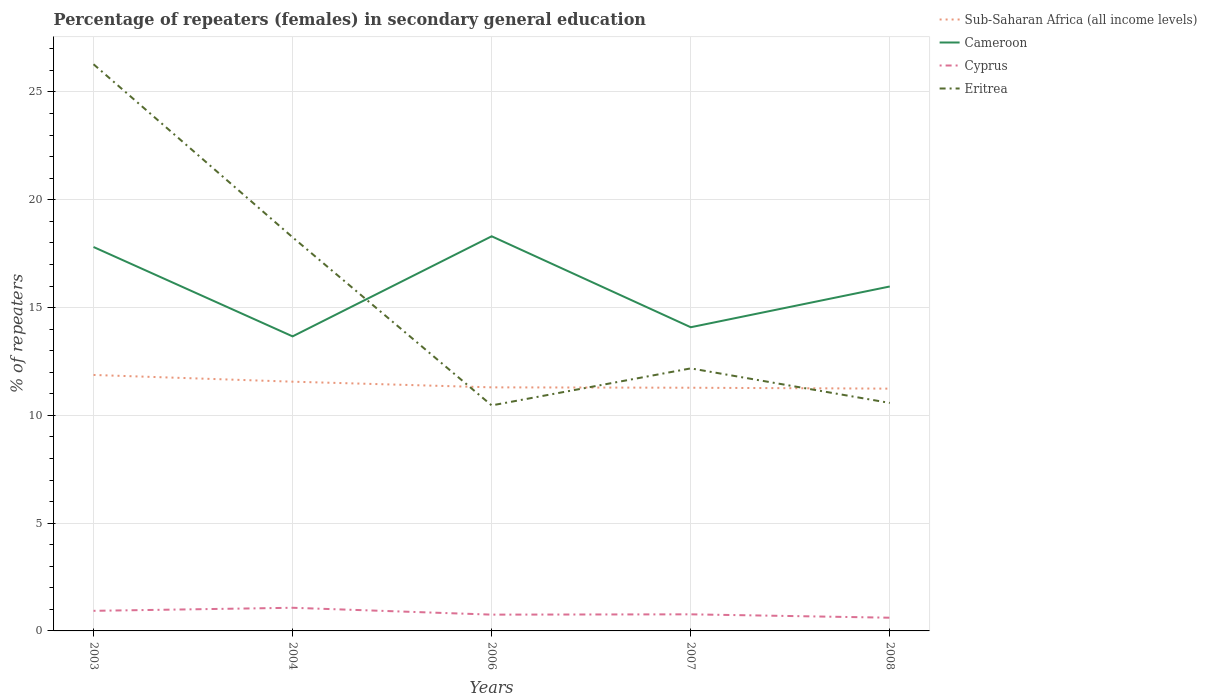How many different coloured lines are there?
Provide a succinct answer. 4. Does the line corresponding to Eritrea intersect with the line corresponding to Cyprus?
Your answer should be compact. No. Is the number of lines equal to the number of legend labels?
Provide a short and direct response. Yes. Across all years, what is the maximum percentage of female repeaters in Cameroon?
Provide a succinct answer. 13.66. In which year was the percentage of female repeaters in Cameroon maximum?
Give a very brief answer. 2004. What is the total percentage of female repeaters in Cyprus in the graph?
Provide a succinct answer. 0.32. What is the difference between the highest and the second highest percentage of female repeaters in Sub-Saharan Africa (all income levels)?
Your answer should be very brief. 0.64. Are the values on the major ticks of Y-axis written in scientific E-notation?
Your answer should be very brief. No. Does the graph contain any zero values?
Offer a terse response. No. Where does the legend appear in the graph?
Ensure brevity in your answer.  Top right. How are the legend labels stacked?
Give a very brief answer. Vertical. What is the title of the graph?
Make the answer very short. Percentage of repeaters (females) in secondary general education. What is the label or title of the X-axis?
Offer a very short reply. Years. What is the label or title of the Y-axis?
Keep it short and to the point. % of repeaters. What is the % of repeaters in Sub-Saharan Africa (all income levels) in 2003?
Offer a very short reply. 11.87. What is the % of repeaters of Cameroon in 2003?
Provide a succinct answer. 17.81. What is the % of repeaters in Cyprus in 2003?
Ensure brevity in your answer.  0.93. What is the % of repeaters in Eritrea in 2003?
Your answer should be very brief. 26.29. What is the % of repeaters in Sub-Saharan Africa (all income levels) in 2004?
Provide a short and direct response. 11.56. What is the % of repeaters of Cameroon in 2004?
Provide a short and direct response. 13.66. What is the % of repeaters of Cyprus in 2004?
Your answer should be compact. 1.07. What is the % of repeaters of Eritrea in 2004?
Provide a succinct answer. 18.26. What is the % of repeaters of Sub-Saharan Africa (all income levels) in 2006?
Provide a short and direct response. 11.3. What is the % of repeaters in Cameroon in 2006?
Provide a short and direct response. 18.31. What is the % of repeaters in Cyprus in 2006?
Keep it short and to the point. 0.76. What is the % of repeaters in Eritrea in 2006?
Offer a terse response. 10.46. What is the % of repeaters of Sub-Saharan Africa (all income levels) in 2007?
Provide a short and direct response. 11.28. What is the % of repeaters of Cameroon in 2007?
Make the answer very short. 14.09. What is the % of repeaters in Cyprus in 2007?
Your answer should be very brief. 0.77. What is the % of repeaters of Eritrea in 2007?
Ensure brevity in your answer.  12.18. What is the % of repeaters of Sub-Saharan Africa (all income levels) in 2008?
Your answer should be compact. 11.24. What is the % of repeaters in Cameroon in 2008?
Your answer should be compact. 15.98. What is the % of repeaters of Cyprus in 2008?
Make the answer very short. 0.61. What is the % of repeaters in Eritrea in 2008?
Provide a short and direct response. 10.58. Across all years, what is the maximum % of repeaters of Sub-Saharan Africa (all income levels)?
Give a very brief answer. 11.87. Across all years, what is the maximum % of repeaters in Cameroon?
Ensure brevity in your answer.  18.31. Across all years, what is the maximum % of repeaters in Cyprus?
Give a very brief answer. 1.07. Across all years, what is the maximum % of repeaters in Eritrea?
Offer a very short reply. 26.29. Across all years, what is the minimum % of repeaters of Sub-Saharan Africa (all income levels)?
Your response must be concise. 11.24. Across all years, what is the minimum % of repeaters in Cameroon?
Your response must be concise. 13.66. Across all years, what is the minimum % of repeaters in Cyprus?
Offer a terse response. 0.61. Across all years, what is the minimum % of repeaters in Eritrea?
Your response must be concise. 10.46. What is the total % of repeaters of Sub-Saharan Africa (all income levels) in the graph?
Your answer should be very brief. 57.26. What is the total % of repeaters of Cameroon in the graph?
Give a very brief answer. 79.85. What is the total % of repeaters of Cyprus in the graph?
Make the answer very short. 4.14. What is the total % of repeaters in Eritrea in the graph?
Make the answer very short. 77.76. What is the difference between the % of repeaters of Sub-Saharan Africa (all income levels) in 2003 and that in 2004?
Provide a short and direct response. 0.31. What is the difference between the % of repeaters of Cameroon in 2003 and that in 2004?
Provide a short and direct response. 4.15. What is the difference between the % of repeaters of Cyprus in 2003 and that in 2004?
Provide a succinct answer. -0.14. What is the difference between the % of repeaters of Eritrea in 2003 and that in 2004?
Provide a succinct answer. 8.03. What is the difference between the % of repeaters of Sub-Saharan Africa (all income levels) in 2003 and that in 2006?
Give a very brief answer. 0.58. What is the difference between the % of repeaters in Cameroon in 2003 and that in 2006?
Your response must be concise. -0.5. What is the difference between the % of repeaters of Cyprus in 2003 and that in 2006?
Give a very brief answer. 0.18. What is the difference between the % of repeaters of Eritrea in 2003 and that in 2006?
Provide a short and direct response. 15.83. What is the difference between the % of repeaters in Sub-Saharan Africa (all income levels) in 2003 and that in 2007?
Ensure brevity in your answer.  0.59. What is the difference between the % of repeaters in Cameroon in 2003 and that in 2007?
Your response must be concise. 3.72. What is the difference between the % of repeaters in Cyprus in 2003 and that in 2007?
Your response must be concise. 0.16. What is the difference between the % of repeaters in Eritrea in 2003 and that in 2007?
Keep it short and to the point. 14.11. What is the difference between the % of repeaters in Sub-Saharan Africa (all income levels) in 2003 and that in 2008?
Make the answer very short. 0.64. What is the difference between the % of repeaters of Cameroon in 2003 and that in 2008?
Your response must be concise. 1.83. What is the difference between the % of repeaters in Cyprus in 2003 and that in 2008?
Give a very brief answer. 0.32. What is the difference between the % of repeaters in Eritrea in 2003 and that in 2008?
Provide a succinct answer. 15.71. What is the difference between the % of repeaters in Sub-Saharan Africa (all income levels) in 2004 and that in 2006?
Your response must be concise. 0.26. What is the difference between the % of repeaters in Cameroon in 2004 and that in 2006?
Give a very brief answer. -4.64. What is the difference between the % of repeaters of Cyprus in 2004 and that in 2006?
Offer a very short reply. 0.32. What is the difference between the % of repeaters in Eritrea in 2004 and that in 2006?
Your answer should be compact. 7.8. What is the difference between the % of repeaters of Sub-Saharan Africa (all income levels) in 2004 and that in 2007?
Your response must be concise. 0.28. What is the difference between the % of repeaters of Cameroon in 2004 and that in 2007?
Keep it short and to the point. -0.42. What is the difference between the % of repeaters in Cyprus in 2004 and that in 2007?
Keep it short and to the point. 0.3. What is the difference between the % of repeaters in Eritrea in 2004 and that in 2007?
Make the answer very short. 6.08. What is the difference between the % of repeaters in Sub-Saharan Africa (all income levels) in 2004 and that in 2008?
Keep it short and to the point. 0.32. What is the difference between the % of repeaters of Cameroon in 2004 and that in 2008?
Your response must be concise. -2.31. What is the difference between the % of repeaters in Cyprus in 2004 and that in 2008?
Provide a short and direct response. 0.46. What is the difference between the % of repeaters in Eritrea in 2004 and that in 2008?
Ensure brevity in your answer.  7.68. What is the difference between the % of repeaters in Sub-Saharan Africa (all income levels) in 2006 and that in 2007?
Your response must be concise. 0.02. What is the difference between the % of repeaters in Cameroon in 2006 and that in 2007?
Give a very brief answer. 4.22. What is the difference between the % of repeaters of Cyprus in 2006 and that in 2007?
Ensure brevity in your answer.  -0.01. What is the difference between the % of repeaters of Eritrea in 2006 and that in 2007?
Make the answer very short. -1.72. What is the difference between the % of repeaters of Sub-Saharan Africa (all income levels) in 2006 and that in 2008?
Provide a succinct answer. 0.06. What is the difference between the % of repeaters of Cameroon in 2006 and that in 2008?
Keep it short and to the point. 2.33. What is the difference between the % of repeaters of Cyprus in 2006 and that in 2008?
Your response must be concise. 0.14. What is the difference between the % of repeaters of Eritrea in 2006 and that in 2008?
Offer a very short reply. -0.11. What is the difference between the % of repeaters in Sub-Saharan Africa (all income levels) in 2007 and that in 2008?
Your response must be concise. 0.04. What is the difference between the % of repeaters in Cameroon in 2007 and that in 2008?
Your answer should be very brief. -1.89. What is the difference between the % of repeaters of Cyprus in 2007 and that in 2008?
Your response must be concise. 0.16. What is the difference between the % of repeaters in Eritrea in 2007 and that in 2008?
Offer a very short reply. 1.6. What is the difference between the % of repeaters in Sub-Saharan Africa (all income levels) in 2003 and the % of repeaters in Cameroon in 2004?
Your answer should be compact. -1.79. What is the difference between the % of repeaters in Sub-Saharan Africa (all income levels) in 2003 and the % of repeaters in Cyprus in 2004?
Your answer should be compact. 10.8. What is the difference between the % of repeaters of Sub-Saharan Africa (all income levels) in 2003 and the % of repeaters of Eritrea in 2004?
Ensure brevity in your answer.  -6.39. What is the difference between the % of repeaters in Cameroon in 2003 and the % of repeaters in Cyprus in 2004?
Your answer should be compact. 16.74. What is the difference between the % of repeaters of Cameroon in 2003 and the % of repeaters of Eritrea in 2004?
Your answer should be very brief. -0.45. What is the difference between the % of repeaters of Cyprus in 2003 and the % of repeaters of Eritrea in 2004?
Your response must be concise. -17.33. What is the difference between the % of repeaters in Sub-Saharan Africa (all income levels) in 2003 and the % of repeaters in Cameroon in 2006?
Keep it short and to the point. -6.43. What is the difference between the % of repeaters of Sub-Saharan Africa (all income levels) in 2003 and the % of repeaters of Cyprus in 2006?
Your response must be concise. 11.12. What is the difference between the % of repeaters in Sub-Saharan Africa (all income levels) in 2003 and the % of repeaters in Eritrea in 2006?
Your answer should be compact. 1.41. What is the difference between the % of repeaters of Cameroon in 2003 and the % of repeaters of Cyprus in 2006?
Make the answer very short. 17.05. What is the difference between the % of repeaters in Cameroon in 2003 and the % of repeaters in Eritrea in 2006?
Make the answer very short. 7.35. What is the difference between the % of repeaters in Cyprus in 2003 and the % of repeaters in Eritrea in 2006?
Your answer should be compact. -9.53. What is the difference between the % of repeaters in Sub-Saharan Africa (all income levels) in 2003 and the % of repeaters in Cameroon in 2007?
Ensure brevity in your answer.  -2.21. What is the difference between the % of repeaters in Sub-Saharan Africa (all income levels) in 2003 and the % of repeaters in Cyprus in 2007?
Give a very brief answer. 11.1. What is the difference between the % of repeaters in Sub-Saharan Africa (all income levels) in 2003 and the % of repeaters in Eritrea in 2007?
Your answer should be very brief. -0.3. What is the difference between the % of repeaters of Cameroon in 2003 and the % of repeaters of Cyprus in 2007?
Your answer should be compact. 17.04. What is the difference between the % of repeaters in Cameroon in 2003 and the % of repeaters in Eritrea in 2007?
Offer a very short reply. 5.63. What is the difference between the % of repeaters in Cyprus in 2003 and the % of repeaters in Eritrea in 2007?
Provide a short and direct response. -11.25. What is the difference between the % of repeaters in Sub-Saharan Africa (all income levels) in 2003 and the % of repeaters in Cameroon in 2008?
Keep it short and to the point. -4.1. What is the difference between the % of repeaters in Sub-Saharan Africa (all income levels) in 2003 and the % of repeaters in Cyprus in 2008?
Keep it short and to the point. 11.26. What is the difference between the % of repeaters of Sub-Saharan Africa (all income levels) in 2003 and the % of repeaters of Eritrea in 2008?
Offer a terse response. 1.3. What is the difference between the % of repeaters of Cameroon in 2003 and the % of repeaters of Cyprus in 2008?
Provide a short and direct response. 17.2. What is the difference between the % of repeaters in Cameroon in 2003 and the % of repeaters in Eritrea in 2008?
Offer a terse response. 7.23. What is the difference between the % of repeaters in Cyprus in 2003 and the % of repeaters in Eritrea in 2008?
Give a very brief answer. -9.64. What is the difference between the % of repeaters of Sub-Saharan Africa (all income levels) in 2004 and the % of repeaters of Cameroon in 2006?
Offer a very short reply. -6.74. What is the difference between the % of repeaters of Sub-Saharan Africa (all income levels) in 2004 and the % of repeaters of Cyprus in 2006?
Offer a terse response. 10.81. What is the difference between the % of repeaters of Sub-Saharan Africa (all income levels) in 2004 and the % of repeaters of Eritrea in 2006?
Provide a short and direct response. 1.1. What is the difference between the % of repeaters in Cameroon in 2004 and the % of repeaters in Cyprus in 2006?
Keep it short and to the point. 12.91. What is the difference between the % of repeaters in Cameroon in 2004 and the % of repeaters in Eritrea in 2006?
Offer a very short reply. 3.2. What is the difference between the % of repeaters in Cyprus in 2004 and the % of repeaters in Eritrea in 2006?
Keep it short and to the point. -9.39. What is the difference between the % of repeaters in Sub-Saharan Africa (all income levels) in 2004 and the % of repeaters in Cameroon in 2007?
Provide a succinct answer. -2.53. What is the difference between the % of repeaters of Sub-Saharan Africa (all income levels) in 2004 and the % of repeaters of Cyprus in 2007?
Offer a terse response. 10.79. What is the difference between the % of repeaters in Sub-Saharan Africa (all income levels) in 2004 and the % of repeaters in Eritrea in 2007?
Your answer should be very brief. -0.62. What is the difference between the % of repeaters of Cameroon in 2004 and the % of repeaters of Cyprus in 2007?
Provide a succinct answer. 12.89. What is the difference between the % of repeaters of Cameroon in 2004 and the % of repeaters of Eritrea in 2007?
Give a very brief answer. 1.48. What is the difference between the % of repeaters in Cyprus in 2004 and the % of repeaters in Eritrea in 2007?
Your answer should be very brief. -11.11. What is the difference between the % of repeaters in Sub-Saharan Africa (all income levels) in 2004 and the % of repeaters in Cameroon in 2008?
Provide a succinct answer. -4.42. What is the difference between the % of repeaters of Sub-Saharan Africa (all income levels) in 2004 and the % of repeaters of Cyprus in 2008?
Your answer should be compact. 10.95. What is the difference between the % of repeaters of Sub-Saharan Africa (all income levels) in 2004 and the % of repeaters of Eritrea in 2008?
Your answer should be very brief. 0.99. What is the difference between the % of repeaters of Cameroon in 2004 and the % of repeaters of Cyprus in 2008?
Offer a terse response. 13.05. What is the difference between the % of repeaters of Cameroon in 2004 and the % of repeaters of Eritrea in 2008?
Keep it short and to the point. 3.09. What is the difference between the % of repeaters of Cyprus in 2004 and the % of repeaters of Eritrea in 2008?
Provide a short and direct response. -9.5. What is the difference between the % of repeaters of Sub-Saharan Africa (all income levels) in 2006 and the % of repeaters of Cameroon in 2007?
Ensure brevity in your answer.  -2.79. What is the difference between the % of repeaters of Sub-Saharan Africa (all income levels) in 2006 and the % of repeaters of Cyprus in 2007?
Provide a succinct answer. 10.53. What is the difference between the % of repeaters of Sub-Saharan Africa (all income levels) in 2006 and the % of repeaters of Eritrea in 2007?
Offer a terse response. -0.88. What is the difference between the % of repeaters of Cameroon in 2006 and the % of repeaters of Cyprus in 2007?
Your answer should be very brief. 17.54. What is the difference between the % of repeaters of Cameroon in 2006 and the % of repeaters of Eritrea in 2007?
Your answer should be compact. 6.13. What is the difference between the % of repeaters in Cyprus in 2006 and the % of repeaters in Eritrea in 2007?
Your answer should be compact. -11.42. What is the difference between the % of repeaters of Sub-Saharan Africa (all income levels) in 2006 and the % of repeaters of Cameroon in 2008?
Your answer should be very brief. -4.68. What is the difference between the % of repeaters in Sub-Saharan Africa (all income levels) in 2006 and the % of repeaters in Cyprus in 2008?
Give a very brief answer. 10.69. What is the difference between the % of repeaters of Sub-Saharan Africa (all income levels) in 2006 and the % of repeaters of Eritrea in 2008?
Keep it short and to the point. 0.72. What is the difference between the % of repeaters in Cameroon in 2006 and the % of repeaters in Cyprus in 2008?
Your response must be concise. 17.69. What is the difference between the % of repeaters of Cameroon in 2006 and the % of repeaters of Eritrea in 2008?
Ensure brevity in your answer.  7.73. What is the difference between the % of repeaters of Cyprus in 2006 and the % of repeaters of Eritrea in 2008?
Offer a terse response. -9.82. What is the difference between the % of repeaters in Sub-Saharan Africa (all income levels) in 2007 and the % of repeaters in Cameroon in 2008?
Offer a very short reply. -4.7. What is the difference between the % of repeaters in Sub-Saharan Africa (all income levels) in 2007 and the % of repeaters in Cyprus in 2008?
Give a very brief answer. 10.67. What is the difference between the % of repeaters of Sub-Saharan Africa (all income levels) in 2007 and the % of repeaters of Eritrea in 2008?
Keep it short and to the point. 0.71. What is the difference between the % of repeaters in Cameroon in 2007 and the % of repeaters in Cyprus in 2008?
Your answer should be compact. 13.47. What is the difference between the % of repeaters in Cameroon in 2007 and the % of repeaters in Eritrea in 2008?
Make the answer very short. 3.51. What is the difference between the % of repeaters of Cyprus in 2007 and the % of repeaters of Eritrea in 2008?
Provide a short and direct response. -9.81. What is the average % of repeaters in Sub-Saharan Africa (all income levels) per year?
Your answer should be compact. 11.45. What is the average % of repeaters of Cameroon per year?
Make the answer very short. 15.97. What is the average % of repeaters in Cyprus per year?
Keep it short and to the point. 0.83. What is the average % of repeaters in Eritrea per year?
Your answer should be very brief. 15.55. In the year 2003, what is the difference between the % of repeaters of Sub-Saharan Africa (all income levels) and % of repeaters of Cameroon?
Ensure brevity in your answer.  -5.94. In the year 2003, what is the difference between the % of repeaters in Sub-Saharan Africa (all income levels) and % of repeaters in Cyprus?
Provide a succinct answer. 10.94. In the year 2003, what is the difference between the % of repeaters of Sub-Saharan Africa (all income levels) and % of repeaters of Eritrea?
Offer a terse response. -14.41. In the year 2003, what is the difference between the % of repeaters in Cameroon and % of repeaters in Cyprus?
Provide a short and direct response. 16.88. In the year 2003, what is the difference between the % of repeaters in Cameroon and % of repeaters in Eritrea?
Your response must be concise. -8.48. In the year 2003, what is the difference between the % of repeaters in Cyprus and % of repeaters in Eritrea?
Offer a terse response. -25.36. In the year 2004, what is the difference between the % of repeaters in Sub-Saharan Africa (all income levels) and % of repeaters in Cameroon?
Make the answer very short. -2.1. In the year 2004, what is the difference between the % of repeaters in Sub-Saharan Africa (all income levels) and % of repeaters in Cyprus?
Your answer should be very brief. 10.49. In the year 2004, what is the difference between the % of repeaters in Sub-Saharan Africa (all income levels) and % of repeaters in Eritrea?
Your answer should be compact. -6.7. In the year 2004, what is the difference between the % of repeaters of Cameroon and % of repeaters of Cyprus?
Provide a succinct answer. 12.59. In the year 2004, what is the difference between the % of repeaters of Cameroon and % of repeaters of Eritrea?
Your response must be concise. -4.6. In the year 2004, what is the difference between the % of repeaters in Cyprus and % of repeaters in Eritrea?
Keep it short and to the point. -17.19. In the year 2006, what is the difference between the % of repeaters in Sub-Saharan Africa (all income levels) and % of repeaters in Cameroon?
Offer a terse response. -7.01. In the year 2006, what is the difference between the % of repeaters of Sub-Saharan Africa (all income levels) and % of repeaters of Cyprus?
Offer a very short reply. 10.54. In the year 2006, what is the difference between the % of repeaters in Sub-Saharan Africa (all income levels) and % of repeaters in Eritrea?
Offer a terse response. 0.84. In the year 2006, what is the difference between the % of repeaters of Cameroon and % of repeaters of Cyprus?
Make the answer very short. 17.55. In the year 2006, what is the difference between the % of repeaters of Cameroon and % of repeaters of Eritrea?
Provide a succinct answer. 7.85. In the year 2006, what is the difference between the % of repeaters in Cyprus and % of repeaters in Eritrea?
Offer a very short reply. -9.71. In the year 2007, what is the difference between the % of repeaters in Sub-Saharan Africa (all income levels) and % of repeaters in Cameroon?
Provide a succinct answer. -2.81. In the year 2007, what is the difference between the % of repeaters in Sub-Saharan Africa (all income levels) and % of repeaters in Cyprus?
Offer a terse response. 10.51. In the year 2007, what is the difference between the % of repeaters in Sub-Saharan Africa (all income levels) and % of repeaters in Eritrea?
Ensure brevity in your answer.  -0.9. In the year 2007, what is the difference between the % of repeaters in Cameroon and % of repeaters in Cyprus?
Give a very brief answer. 13.32. In the year 2007, what is the difference between the % of repeaters of Cameroon and % of repeaters of Eritrea?
Give a very brief answer. 1.91. In the year 2007, what is the difference between the % of repeaters in Cyprus and % of repeaters in Eritrea?
Your response must be concise. -11.41. In the year 2008, what is the difference between the % of repeaters in Sub-Saharan Africa (all income levels) and % of repeaters in Cameroon?
Your answer should be compact. -4.74. In the year 2008, what is the difference between the % of repeaters of Sub-Saharan Africa (all income levels) and % of repeaters of Cyprus?
Give a very brief answer. 10.63. In the year 2008, what is the difference between the % of repeaters in Sub-Saharan Africa (all income levels) and % of repeaters in Eritrea?
Ensure brevity in your answer.  0.66. In the year 2008, what is the difference between the % of repeaters of Cameroon and % of repeaters of Cyprus?
Your response must be concise. 15.37. In the year 2008, what is the difference between the % of repeaters of Cameroon and % of repeaters of Eritrea?
Keep it short and to the point. 5.4. In the year 2008, what is the difference between the % of repeaters in Cyprus and % of repeaters in Eritrea?
Provide a succinct answer. -9.96. What is the ratio of the % of repeaters of Cameroon in 2003 to that in 2004?
Provide a succinct answer. 1.3. What is the ratio of the % of repeaters in Cyprus in 2003 to that in 2004?
Ensure brevity in your answer.  0.87. What is the ratio of the % of repeaters in Eritrea in 2003 to that in 2004?
Provide a short and direct response. 1.44. What is the ratio of the % of repeaters of Sub-Saharan Africa (all income levels) in 2003 to that in 2006?
Ensure brevity in your answer.  1.05. What is the ratio of the % of repeaters in Cameroon in 2003 to that in 2006?
Your answer should be very brief. 0.97. What is the ratio of the % of repeaters of Cyprus in 2003 to that in 2006?
Offer a very short reply. 1.23. What is the ratio of the % of repeaters in Eritrea in 2003 to that in 2006?
Ensure brevity in your answer.  2.51. What is the ratio of the % of repeaters in Sub-Saharan Africa (all income levels) in 2003 to that in 2007?
Give a very brief answer. 1.05. What is the ratio of the % of repeaters in Cameroon in 2003 to that in 2007?
Offer a terse response. 1.26. What is the ratio of the % of repeaters in Cyprus in 2003 to that in 2007?
Your answer should be compact. 1.21. What is the ratio of the % of repeaters of Eritrea in 2003 to that in 2007?
Keep it short and to the point. 2.16. What is the ratio of the % of repeaters of Sub-Saharan Africa (all income levels) in 2003 to that in 2008?
Offer a very short reply. 1.06. What is the ratio of the % of repeaters of Cameroon in 2003 to that in 2008?
Ensure brevity in your answer.  1.11. What is the ratio of the % of repeaters in Cyprus in 2003 to that in 2008?
Give a very brief answer. 1.52. What is the ratio of the % of repeaters in Eritrea in 2003 to that in 2008?
Provide a succinct answer. 2.49. What is the ratio of the % of repeaters in Sub-Saharan Africa (all income levels) in 2004 to that in 2006?
Offer a terse response. 1.02. What is the ratio of the % of repeaters in Cameroon in 2004 to that in 2006?
Provide a succinct answer. 0.75. What is the ratio of the % of repeaters in Cyprus in 2004 to that in 2006?
Ensure brevity in your answer.  1.42. What is the ratio of the % of repeaters of Eritrea in 2004 to that in 2006?
Your answer should be compact. 1.75. What is the ratio of the % of repeaters in Sub-Saharan Africa (all income levels) in 2004 to that in 2007?
Your answer should be compact. 1.02. What is the ratio of the % of repeaters in Cameroon in 2004 to that in 2007?
Your response must be concise. 0.97. What is the ratio of the % of repeaters of Cyprus in 2004 to that in 2007?
Your answer should be compact. 1.4. What is the ratio of the % of repeaters in Eritrea in 2004 to that in 2007?
Offer a very short reply. 1.5. What is the ratio of the % of repeaters of Sub-Saharan Africa (all income levels) in 2004 to that in 2008?
Provide a succinct answer. 1.03. What is the ratio of the % of repeaters of Cameroon in 2004 to that in 2008?
Your answer should be compact. 0.86. What is the ratio of the % of repeaters of Cyprus in 2004 to that in 2008?
Offer a very short reply. 1.75. What is the ratio of the % of repeaters of Eritrea in 2004 to that in 2008?
Ensure brevity in your answer.  1.73. What is the ratio of the % of repeaters in Sub-Saharan Africa (all income levels) in 2006 to that in 2007?
Provide a succinct answer. 1. What is the ratio of the % of repeaters of Cameroon in 2006 to that in 2007?
Offer a terse response. 1.3. What is the ratio of the % of repeaters in Cyprus in 2006 to that in 2007?
Your response must be concise. 0.98. What is the ratio of the % of repeaters in Eritrea in 2006 to that in 2007?
Your answer should be compact. 0.86. What is the ratio of the % of repeaters in Cameroon in 2006 to that in 2008?
Your answer should be compact. 1.15. What is the ratio of the % of repeaters of Cyprus in 2006 to that in 2008?
Ensure brevity in your answer.  1.23. What is the ratio of the % of repeaters in Cameroon in 2007 to that in 2008?
Offer a terse response. 0.88. What is the ratio of the % of repeaters of Cyprus in 2007 to that in 2008?
Provide a short and direct response. 1.26. What is the ratio of the % of repeaters of Eritrea in 2007 to that in 2008?
Your response must be concise. 1.15. What is the difference between the highest and the second highest % of repeaters in Sub-Saharan Africa (all income levels)?
Make the answer very short. 0.31. What is the difference between the highest and the second highest % of repeaters of Cameroon?
Provide a short and direct response. 0.5. What is the difference between the highest and the second highest % of repeaters in Cyprus?
Your answer should be compact. 0.14. What is the difference between the highest and the second highest % of repeaters in Eritrea?
Make the answer very short. 8.03. What is the difference between the highest and the lowest % of repeaters in Sub-Saharan Africa (all income levels)?
Provide a succinct answer. 0.64. What is the difference between the highest and the lowest % of repeaters of Cameroon?
Your answer should be very brief. 4.64. What is the difference between the highest and the lowest % of repeaters in Cyprus?
Offer a terse response. 0.46. What is the difference between the highest and the lowest % of repeaters in Eritrea?
Your answer should be very brief. 15.83. 